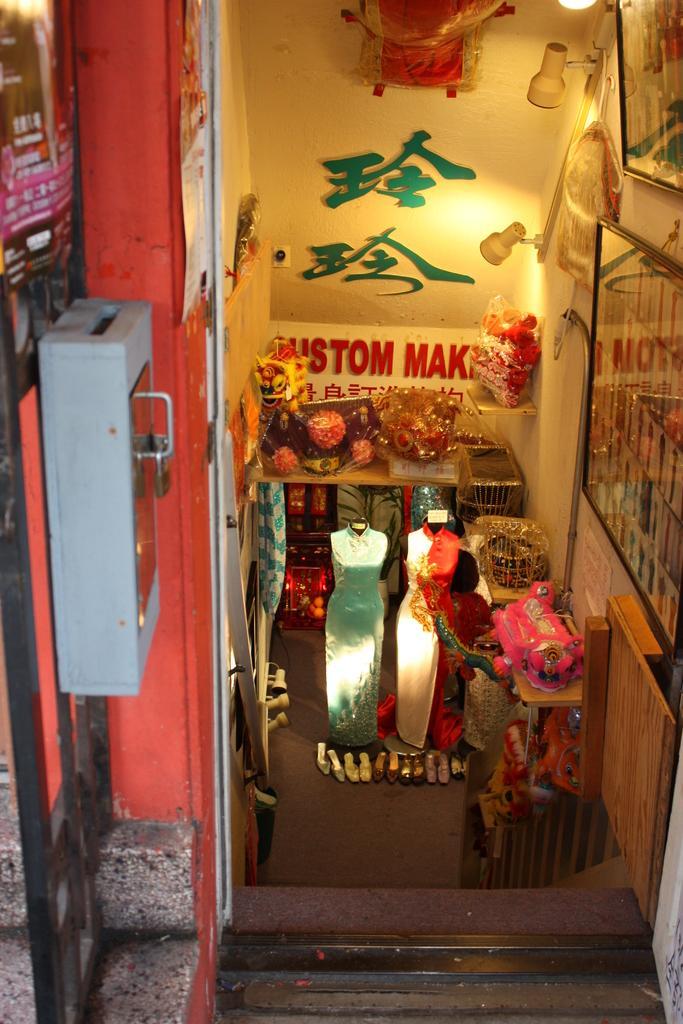Can you describe this image briefly? In this image we can see mannequins, few foot wears and few other objects on the floor, there are photo frames and lights to the wall on the right side, there is a box on the left side and text and an object to the wall in the background. 